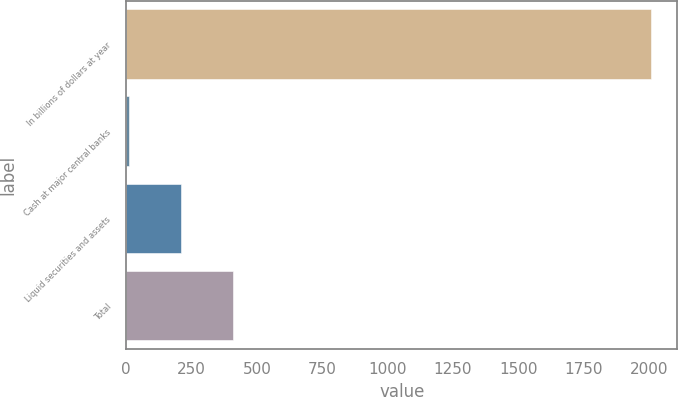Convert chart. <chart><loc_0><loc_0><loc_500><loc_500><bar_chart><fcel>In billions of dollars at year<fcel>Cash at major central banks<fcel>Liquid securities and assets<fcel>Total<nl><fcel>2009<fcel>10.4<fcel>210.26<fcel>410.12<nl></chart> 